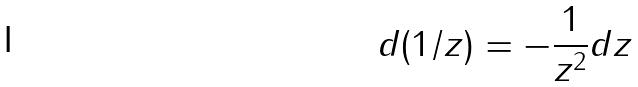Convert formula to latex. <formula><loc_0><loc_0><loc_500><loc_500>d ( 1 / z ) = - \frac { 1 } { z ^ { 2 } } d z</formula> 